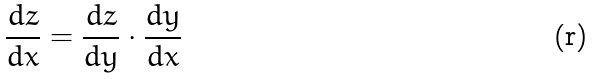<formula> <loc_0><loc_0><loc_500><loc_500>\frac { d z } { d x } = \frac { d z } { d y } \cdot \frac { d y } { d x }</formula> 